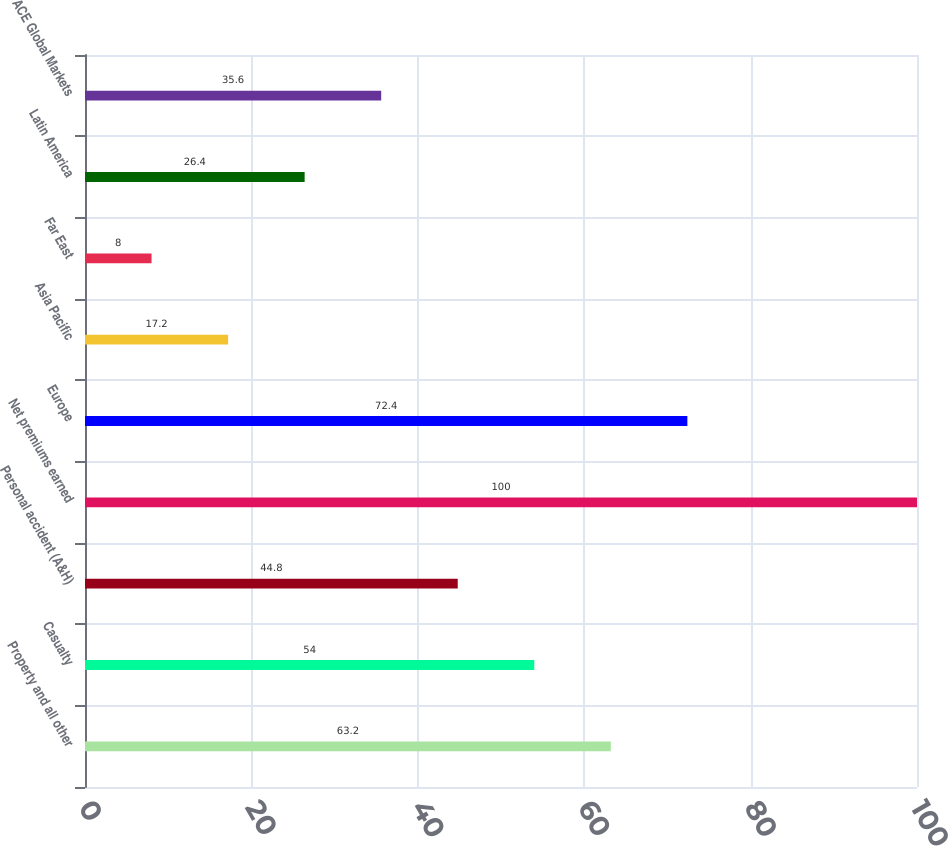Convert chart. <chart><loc_0><loc_0><loc_500><loc_500><bar_chart><fcel>Property and all other<fcel>Casualty<fcel>Personal accident (A&H)<fcel>Net premiums earned<fcel>Europe<fcel>Asia Pacific<fcel>Far East<fcel>Latin America<fcel>ACE Global Markets<nl><fcel>63.2<fcel>54<fcel>44.8<fcel>100<fcel>72.4<fcel>17.2<fcel>8<fcel>26.4<fcel>35.6<nl></chart> 